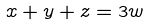<formula> <loc_0><loc_0><loc_500><loc_500>x + y + z = 3 w</formula> 